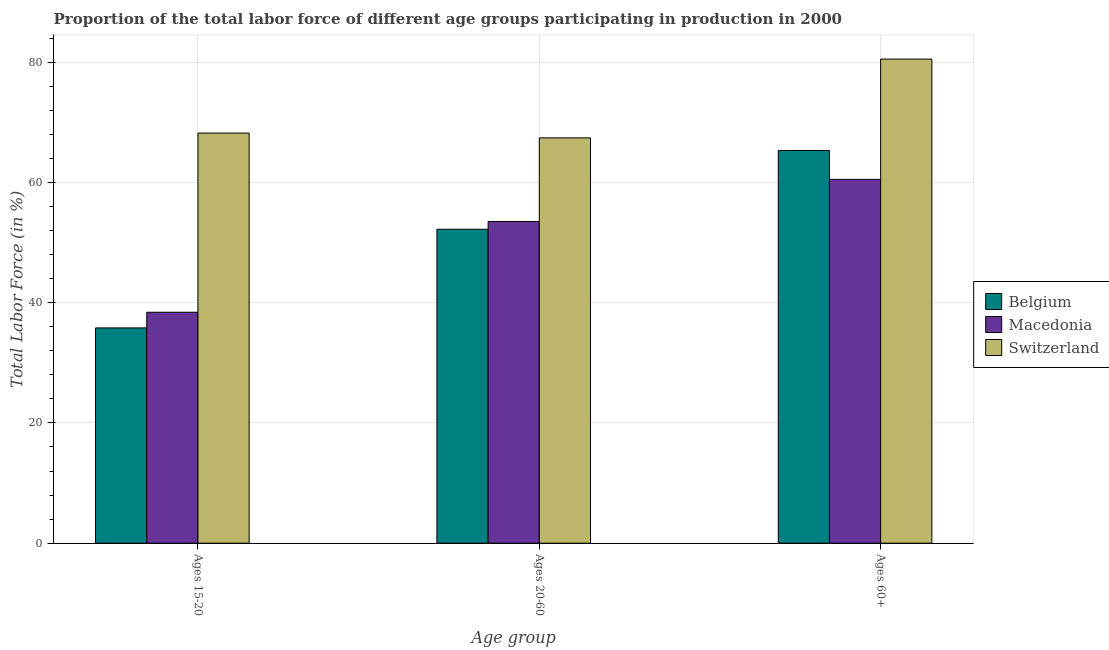Are the number of bars per tick equal to the number of legend labels?
Keep it short and to the point. Yes. Are the number of bars on each tick of the X-axis equal?
Offer a terse response. Yes. How many bars are there on the 2nd tick from the right?
Make the answer very short. 3. What is the label of the 3rd group of bars from the left?
Make the answer very short. Ages 60+. What is the percentage of labor force above age 60 in Switzerland?
Make the answer very short. 80.5. Across all countries, what is the maximum percentage of labor force within the age group 15-20?
Ensure brevity in your answer.  68.2. Across all countries, what is the minimum percentage of labor force within the age group 15-20?
Your answer should be very brief. 35.8. In which country was the percentage of labor force within the age group 20-60 maximum?
Make the answer very short. Switzerland. In which country was the percentage of labor force within the age group 15-20 minimum?
Your answer should be compact. Belgium. What is the total percentage of labor force above age 60 in the graph?
Keep it short and to the point. 206.3. What is the difference between the percentage of labor force within the age group 15-20 in Macedonia and that in Switzerland?
Make the answer very short. -29.8. What is the difference between the percentage of labor force within the age group 20-60 in Belgium and the percentage of labor force within the age group 15-20 in Macedonia?
Provide a succinct answer. 13.8. What is the average percentage of labor force within the age group 15-20 per country?
Ensure brevity in your answer.  47.47. What is the difference between the percentage of labor force above age 60 and percentage of labor force within the age group 15-20 in Belgium?
Your response must be concise. 29.5. What is the ratio of the percentage of labor force within the age group 20-60 in Macedonia to that in Switzerland?
Ensure brevity in your answer.  0.79. Is the percentage of labor force within the age group 20-60 in Switzerland less than that in Macedonia?
Offer a very short reply. No. Is the difference between the percentage of labor force above age 60 in Macedonia and Switzerland greater than the difference between the percentage of labor force within the age group 20-60 in Macedonia and Switzerland?
Offer a terse response. No. What is the difference between the highest and the second highest percentage of labor force within the age group 20-60?
Give a very brief answer. 13.9. What is the difference between the highest and the lowest percentage of labor force within the age group 15-20?
Make the answer very short. 32.4. In how many countries, is the percentage of labor force within the age group 15-20 greater than the average percentage of labor force within the age group 15-20 taken over all countries?
Make the answer very short. 1. Is the sum of the percentage of labor force within the age group 15-20 in Belgium and Switzerland greater than the maximum percentage of labor force within the age group 20-60 across all countries?
Keep it short and to the point. Yes. What does the 1st bar from the left in Ages 20-60 represents?
Your answer should be compact. Belgium. What does the 2nd bar from the right in Ages 20-60 represents?
Offer a terse response. Macedonia. How many countries are there in the graph?
Your answer should be compact. 3. What is the difference between two consecutive major ticks on the Y-axis?
Offer a terse response. 20. Are the values on the major ticks of Y-axis written in scientific E-notation?
Keep it short and to the point. No. Does the graph contain any zero values?
Offer a very short reply. No. Does the graph contain grids?
Your response must be concise. Yes. How many legend labels are there?
Offer a terse response. 3. What is the title of the graph?
Your response must be concise. Proportion of the total labor force of different age groups participating in production in 2000. What is the label or title of the X-axis?
Offer a very short reply. Age group. What is the Total Labor Force (in %) in Belgium in Ages 15-20?
Your response must be concise. 35.8. What is the Total Labor Force (in %) in Macedonia in Ages 15-20?
Your answer should be compact. 38.4. What is the Total Labor Force (in %) in Switzerland in Ages 15-20?
Your answer should be compact. 68.2. What is the Total Labor Force (in %) in Belgium in Ages 20-60?
Your answer should be very brief. 52.2. What is the Total Labor Force (in %) of Macedonia in Ages 20-60?
Offer a terse response. 53.5. What is the Total Labor Force (in %) in Switzerland in Ages 20-60?
Ensure brevity in your answer.  67.4. What is the Total Labor Force (in %) of Belgium in Ages 60+?
Offer a terse response. 65.3. What is the Total Labor Force (in %) in Macedonia in Ages 60+?
Provide a succinct answer. 60.5. What is the Total Labor Force (in %) in Switzerland in Ages 60+?
Provide a succinct answer. 80.5. Across all Age group, what is the maximum Total Labor Force (in %) in Belgium?
Keep it short and to the point. 65.3. Across all Age group, what is the maximum Total Labor Force (in %) in Macedonia?
Give a very brief answer. 60.5. Across all Age group, what is the maximum Total Labor Force (in %) of Switzerland?
Ensure brevity in your answer.  80.5. Across all Age group, what is the minimum Total Labor Force (in %) of Belgium?
Your answer should be compact. 35.8. Across all Age group, what is the minimum Total Labor Force (in %) in Macedonia?
Provide a short and direct response. 38.4. Across all Age group, what is the minimum Total Labor Force (in %) in Switzerland?
Keep it short and to the point. 67.4. What is the total Total Labor Force (in %) of Belgium in the graph?
Offer a very short reply. 153.3. What is the total Total Labor Force (in %) in Macedonia in the graph?
Offer a terse response. 152.4. What is the total Total Labor Force (in %) of Switzerland in the graph?
Keep it short and to the point. 216.1. What is the difference between the Total Labor Force (in %) in Belgium in Ages 15-20 and that in Ages 20-60?
Your answer should be compact. -16.4. What is the difference between the Total Labor Force (in %) in Macedonia in Ages 15-20 and that in Ages 20-60?
Provide a short and direct response. -15.1. What is the difference between the Total Labor Force (in %) in Switzerland in Ages 15-20 and that in Ages 20-60?
Make the answer very short. 0.8. What is the difference between the Total Labor Force (in %) in Belgium in Ages 15-20 and that in Ages 60+?
Offer a terse response. -29.5. What is the difference between the Total Labor Force (in %) of Macedonia in Ages 15-20 and that in Ages 60+?
Offer a very short reply. -22.1. What is the difference between the Total Labor Force (in %) of Switzerland in Ages 15-20 and that in Ages 60+?
Offer a very short reply. -12.3. What is the difference between the Total Labor Force (in %) in Belgium in Ages 20-60 and that in Ages 60+?
Offer a very short reply. -13.1. What is the difference between the Total Labor Force (in %) of Macedonia in Ages 20-60 and that in Ages 60+?
Provide a short and direct response. -7. What is the difference between the Total Labor Force (in %) in Switzerland in Ages 20-60 and that in Ages 60+?
Offer a terse response. -13.1. What is the difference between the Total Labor Force (in %) in Belgium in Ages 15-20 and the Total Labor Force (in %) in Macedonia in Ages 20-60?
Offer a very short reply. -17.7. What is the difference between the Total Labor Force (in %) in Belgium in Ages 15-20 and the Total Labor Force (in %) in Switzerland in Ages 20-60?
Your answer should be compact. -31.6. What is the difference between the Total Labor Force (in %) of Macedonia in Ages 15-20 and the Total Labor Force (in %) of Switzerland in Ages 20-60?
Make the answer very short. -29. What is the difference between the Total Labor Force (in %) in Belgium in Ages 15-20 and the Total Labor Force (in %) in Macedonia in Ages 60+?
Give a very brief answer. -24.7. What is the difference between the Total Labor Force (in %) of Belgium in Ages 15-20 and the Total Labor Force (in %) of Switzerland in Ages 60+?
Make the answer very short. -44.7. What is the difference between the Total Labor Force (in %) in Macedonia in Ages 15-20 and the Total Labor Force (in %) in Switzerland in Ages 60+?
Keep it short and to the point. -42.1. What is the difference between the Total Labor Force (in %) in Belgium in Ages 20-60 and the Total Labor Force (in %) in Switzerland in Ages 60+?
Your response must be concise. -28.3. What is the difference between the Total Labor Force (in %) of Macedonia in Ages 20-60 and the Total Labor Force (in %) of Switzerland in Ages 60+?
Provide a short and direct response. -27. What is the average Total Labor Force (in %) of Belgium per Age group?
Provide a succinct answer. 51.1. What is the average Total Labor Force (in %) in Macedonia per Age group?
Provide a short and direct response. 50.8. What is the average Total Labor Force (in %) of Switzerland per Age group?
Keep it short and to the point. 72.03. What is the difference between the Total Labor Force (in %) of Belgium and Total Labor Force (in %) of Macedonia in Ages 15-20?
Your answer should be compact. -2.6. What is the difference between the Total Labor Force (in %) in Belgium and Total Labor Force (in %) in Switzerland in Ages 15-20?
Offer a very short reply. -32.4. What is the difference between the Total Labor Force (in %) of Macedonia and Total Labor Force (in %) of Switzerland in Ages 15-20?
Offer a very short reply. -29.8. What is the difference between the Total Labor Force (in %) of Belgium and Total Labor Force (in %) of Macedonia in Ages 20-60?
Provide a short and direct response. -1.3. What is the difference between the Total Labor Force (in %) in Belgium and Total Labor Force (in %) in Switzerland in Ages 20-60?
Ensure brevity in your answer.  -15.2. What is the difference between the Total Labor Force (in %) in Macedonia and Total Labor Force (in %) in Switzerland in Ages 20-60?
Your answer should be compact. -13.9. What is the difference between the Total Labor Force (in %) in Belgium and Total Labor Force (in %) in Switzerland in Ages 60+?
Provide a succinct answer. -15.2. What is the difference between the Total Labor Force (in %) in Macedonia and Total Labor Force (in %) in Switzerland in Ages 60+?
Offer a very short reply. -20. What is the ratio of the Total Labor Force (in %) in Belgium in Ages 15-20 to that in Ages 20-60?
Offer a terse response. 0.69. What is the ratio of the Total Labor Force (in %) of Macedonia in Ages 15-20 to that in Ages 20-60?
Make the answer very short. 0.72. What is the ratio of the Total Labor Force (in %) of Switzerland in Ages 15-20 to that in Ages 20-60?
Ensure brevity in your answer.  1.01. What is the ratio of the Total Labor Force (in %) of Belgium in Ages 15-20 to that in Ages 60+?
Your response must be concise. 0.55. What is the ratio of the Total Labor Force (in %) of Macedonia in Ages 15-20 to that in Ages 60+?
Make the answer very short. 0.63. What is the ratio of the Total Labor Force (in %) in Switzerland in Ages 15-20 to that in Ages 60+?
Your response must be concise. 0.85. What is the ratio of the Total Labor Force (in %) of Belgium in Ages 20-60 to that in Ages 60+?
Provide a succinct answer. 0.8. What is the ratio of the Total Labor Force (in %) in Macedonia in Ages 20-60 to that in Ages 60+?
Your response must be concise. 0.88. What is the ratio of the Total Labor Force (in %) in Switzerland in Ages 20-60 to that in Ages 60+?
Give a very brief answer. 0.84. What is the difference between the highest and the second highest Total Labor Force (in %) in Belgium?
Your response must be concise. 13.1. What is the difference between the highest and the second highest Total Labor Force (in %) of Switzerland?
Make the answer very short. 12.3. What is the difference between the highest and the lowest Total Labor Force (in %) in Belgium?
Your answer should be very brief. 29.5. What is the difference between the highest and the lowest Total Labor Force (in %) in Macedonia?
Give a very brief answer. 22.1. 